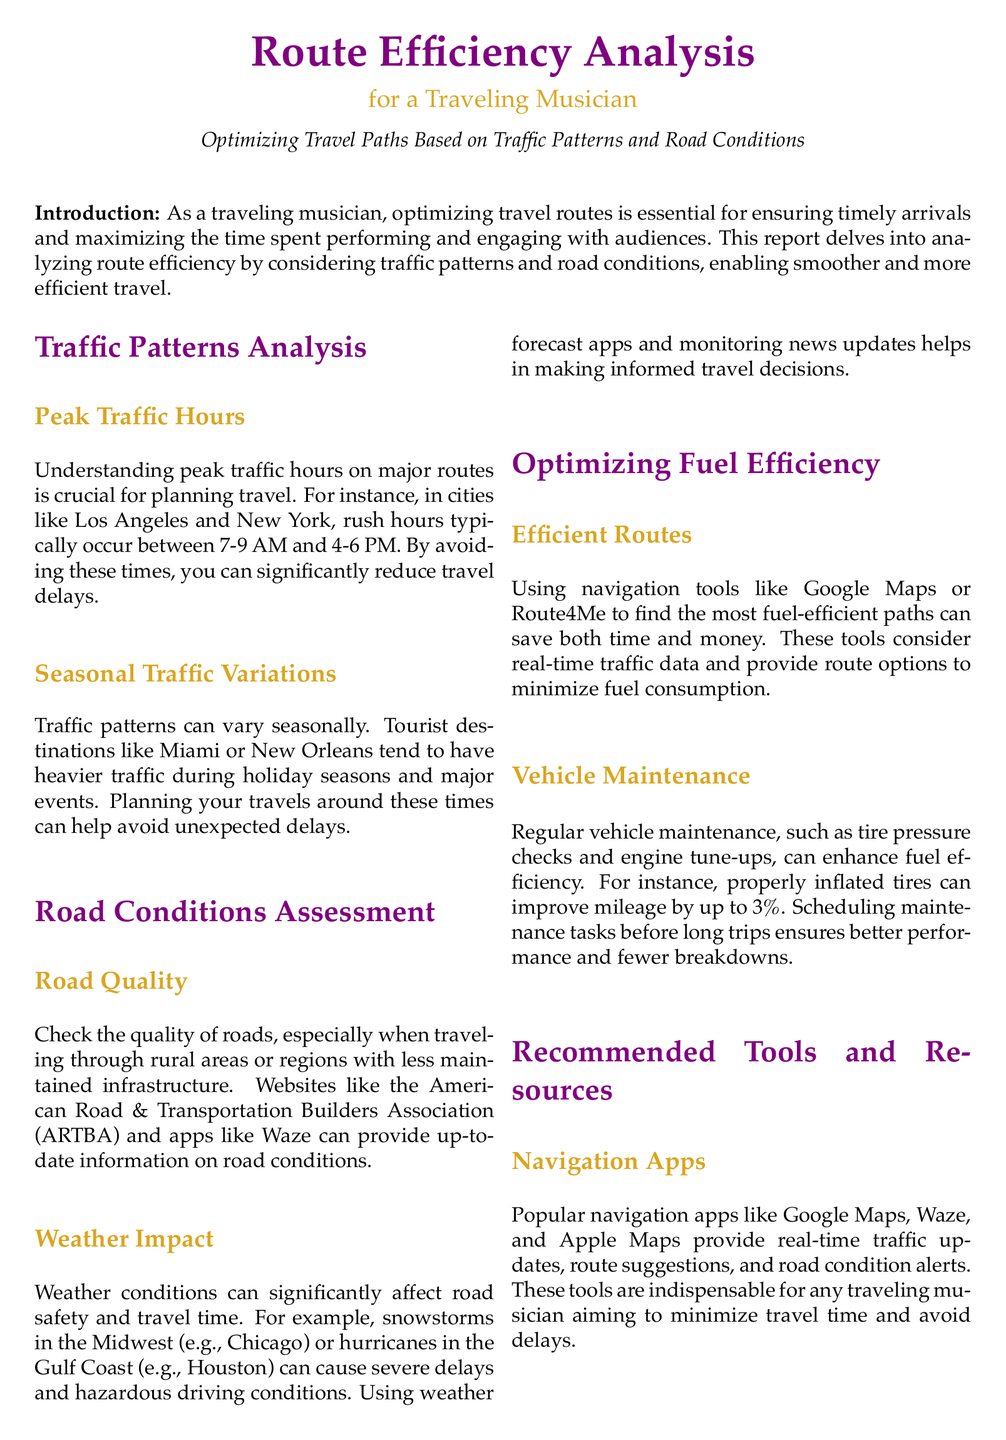what are peak traffic hours in Los Angeles? The report specifies that peak traffic hours typically occur between 7-9 AM and 4-6 PM in Los Angeles.
Answer: 7-9 AM and 4-6 PM which app provides up-to-date information on road conditions? The document indicates that websites like the American Road & Transportation Builders Association (ARTBA) and apps like Waze can provide this information.
Answer: Waze how can properly inflated tires affect mileage? The document states that properly inflated tires can improve mileage by up to 3%.
Answer: up to 3% what is a recommended navigation app mentioned in the document? The report lists popular navigation apps such as Google Maps, Waze, and Apple Maps for real-time traffic updates.
Answer: Google Maps how do seasonal traffic variations impact travel? The document explains that tourist destinations tend to have heavier traffic during holiday seasons and major events, affecting travel efficiency.
Answer: heavier traffic what tools can help planning long journeys with multiple stops? According to the report, platforms like Roadtrippers and Furkot assist in planning long journeys with multiple stops.
Answer: Roadtrippers what factor significantly affects road safety and travel time? The document emphasizes that weather conditions can significantly affect road safety and travel time.
Answer: weather conditions what is the main purpose of this traffic report? The report's main purpose is to optimize travel paths based on traffic patterns and road conditions for traveling musicians.
Answer: optimize travel paths 